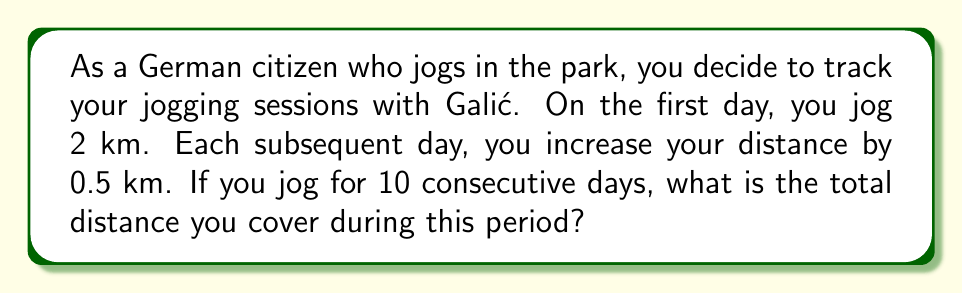Can you answer this question? To solve this problem, we need to recognize that this is an arithmetic sequence with a common difference of 0.5 km. Let's break it down step-by-step:

1. Identify the sequence:
   First term, $a_1 = 2$ km
   Common difference, $d = 0.5$ km
   Number of terms, $n = 10$ days

2. Find the last term of the sequence:
   $a_n = a_1 + (n-1)d$
   $a_{10} = 2 + (10-1)(0.5) = 2 + 4.5 = 6.5$ km

3. Use the formula for the sum of an arithmetic sequence:
   $$S_n = \frac{n}{2}(a_1 + a_n)$$
   Where $S_n$ is the sum of the sequence, $n$ is the number of terms, $a_1$ is the first term, and $a_n$ is the last term.

4. Substitute the values:
   $$S_{10} = \frac{10}{2}(2 + 6.5)$$

5. Calculate:
   $$S_{10} = 5(8.5) = 42.5$$

Therefore, the total distance covered over the 10 days is 42.5 km.
Answer: $42.5$ km 